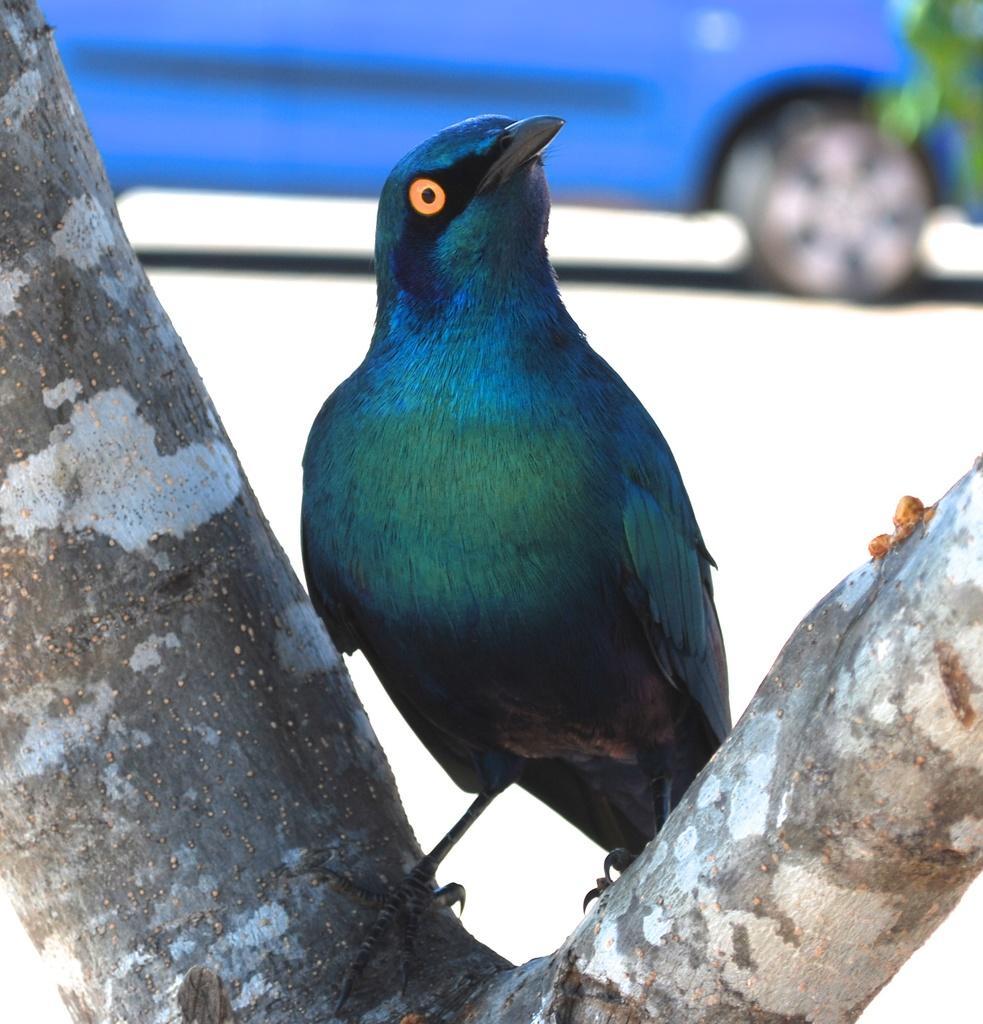Describe this image in one or two sentences. In the center of the image we can see a bird on the barks of a tree. In the background we can see the blue color car on the road. We can also see the leaves. 